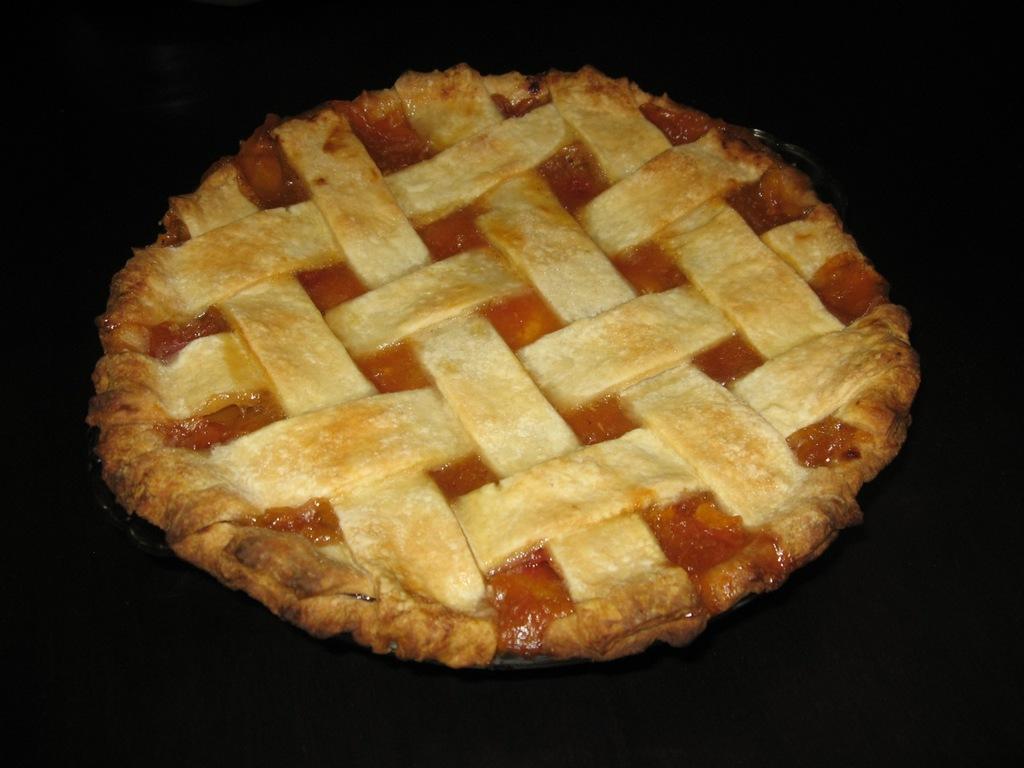Describe this image in one or two sentences. In this picture I can see a pie, and there is dark background. 